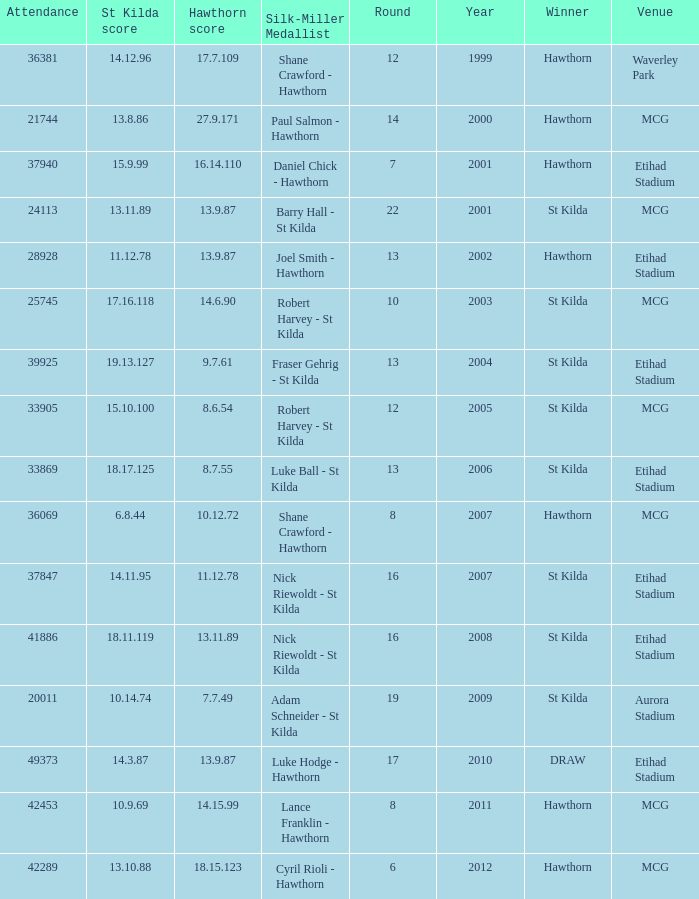What the listed in round when the hawthorn score is 17.7.109? 12.0. 